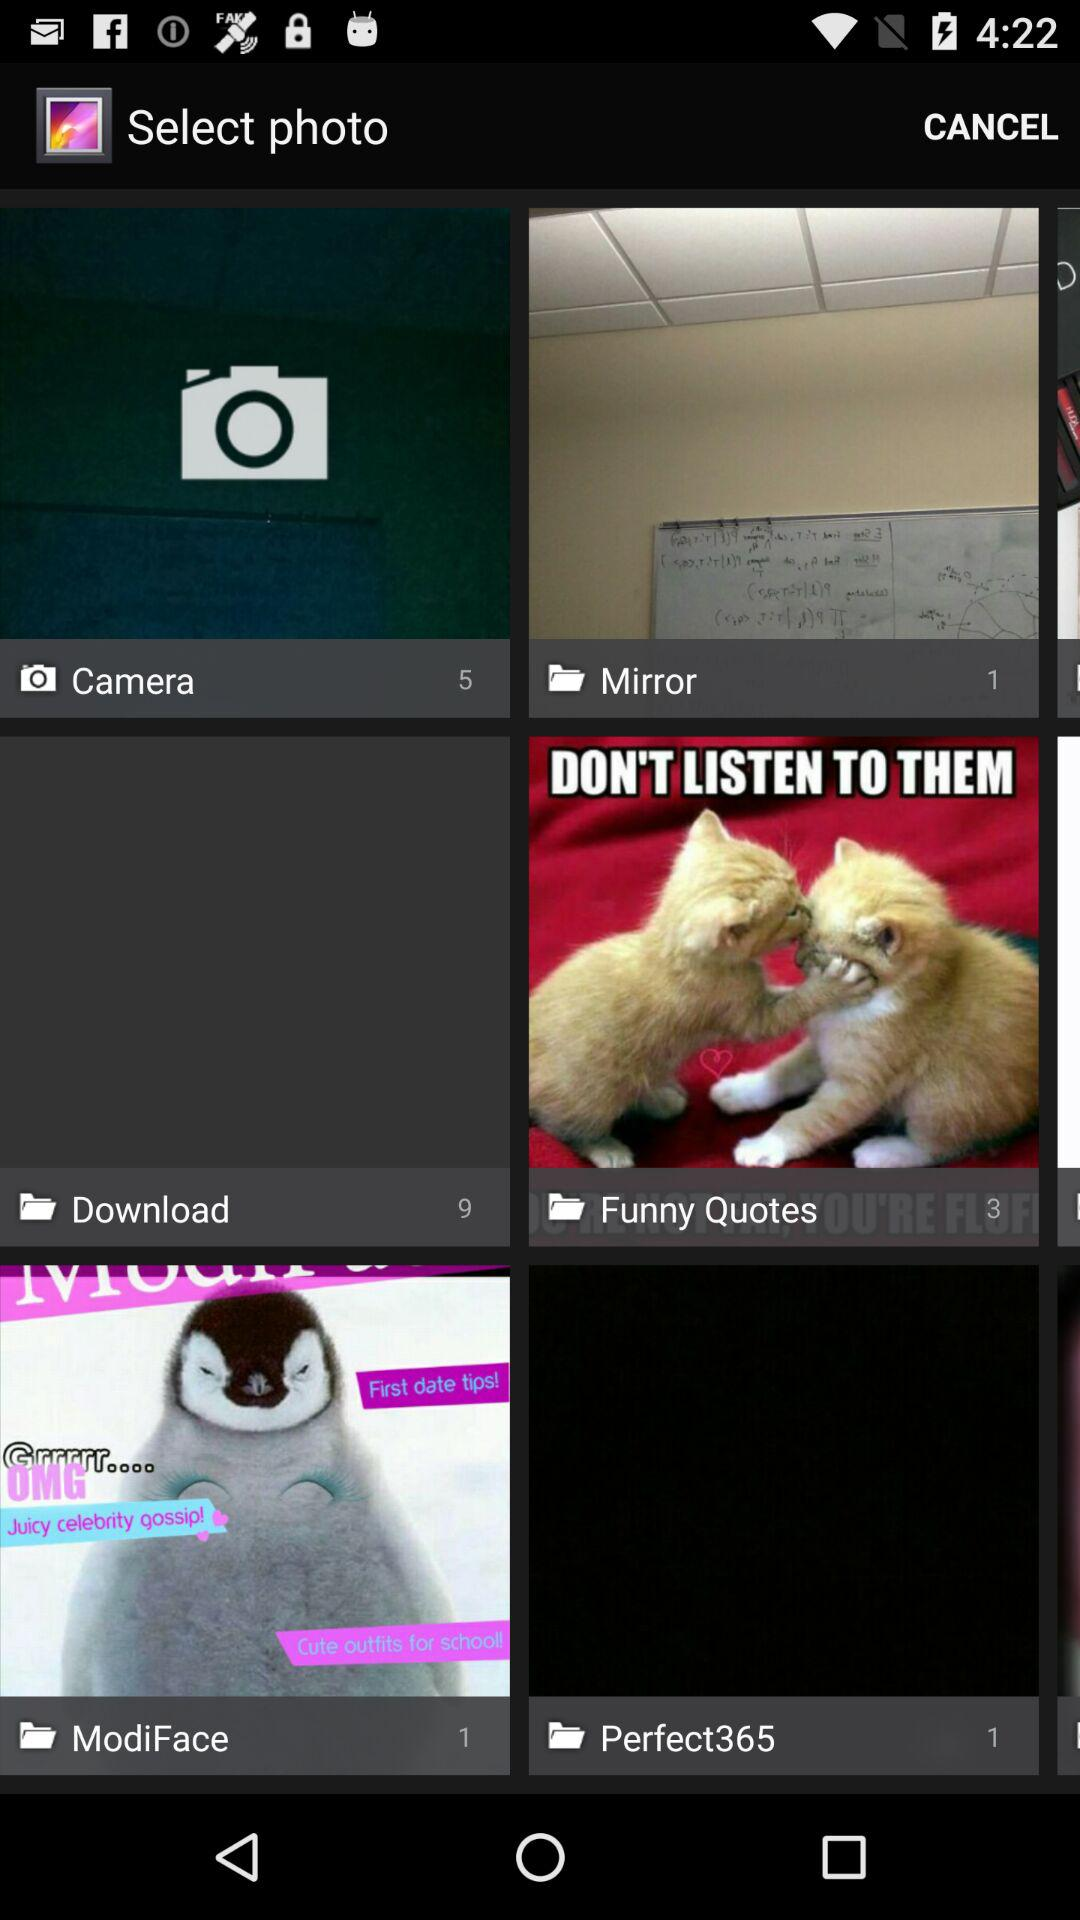What is the number of files in "Perfect365"? The number of files is 1. 